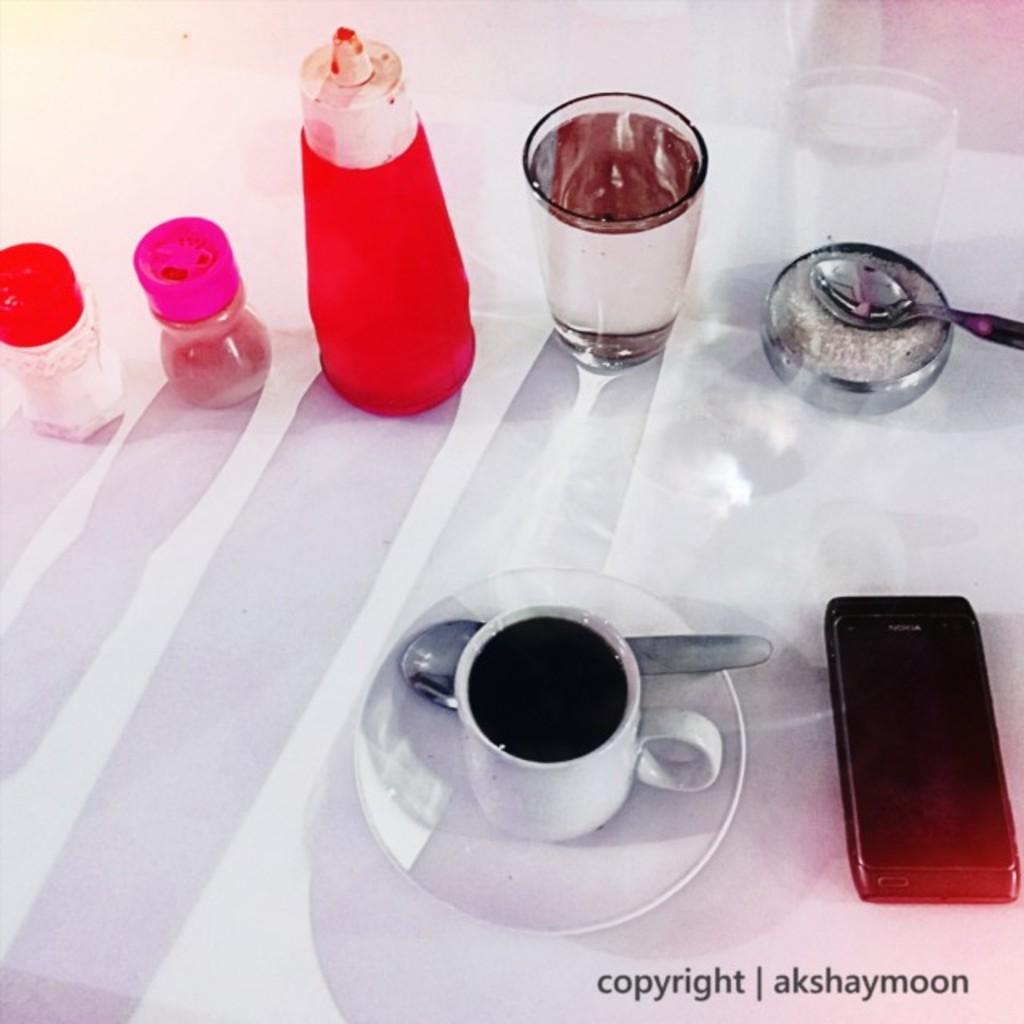What piece of furniture is present in the image? There is a table in the image. What type of beverage is in the cup on the table? There is coffee in the cup on the table. What is used to hold the cup on the table? There is a saucer on the table. What utensil is on the table? There is a spoon on the table. What is hanging from the ceiling in the image? There is a mobile on the table. What is used for eating or stirring in the image? There is a spoon on the table. What is used for drinking water in the image? There is a glass with water on the table. What is used for adding sauce to the food in the image? There is a sauce bottle on the table. How many other bottles are on the table besides the sauce bottle? There are two other bottles on the table. What type of yam is being cooked in the image? There is no yam present in the image; it features a table with various items on it. How many bottles of fire are on the table in the image? There is no fire or bottle of fire present in the image. 